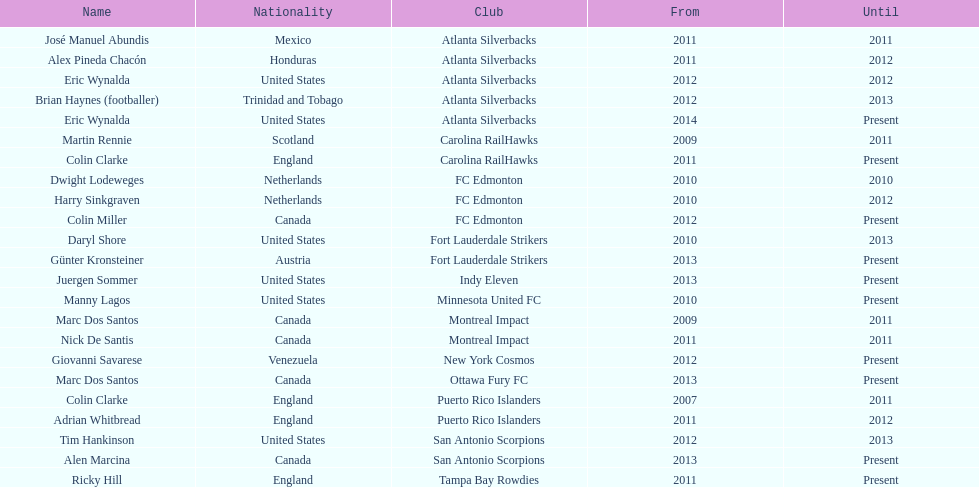What is the overall number of coaches on the list originating from canada? 5. 